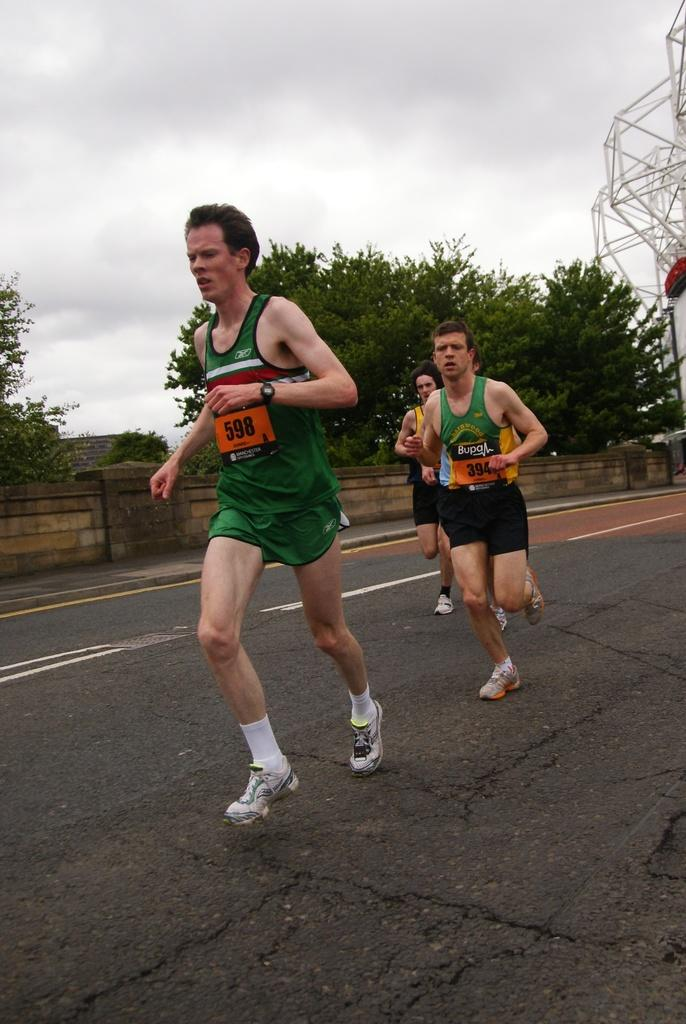What are the people in the image doing? The people in the image are running on the road. What can be seen in the background of the image? There are trees and the sky visible in the background of the image. What structure is present on the right side of the image? There is a tower on the right side of the image. What else can be seen in the image? There is a wall in the image. What type of clam is being played by the band in the image? There is no band or clam present in the image; it features people running on the road, trees, sky, a tower, and a wall. 